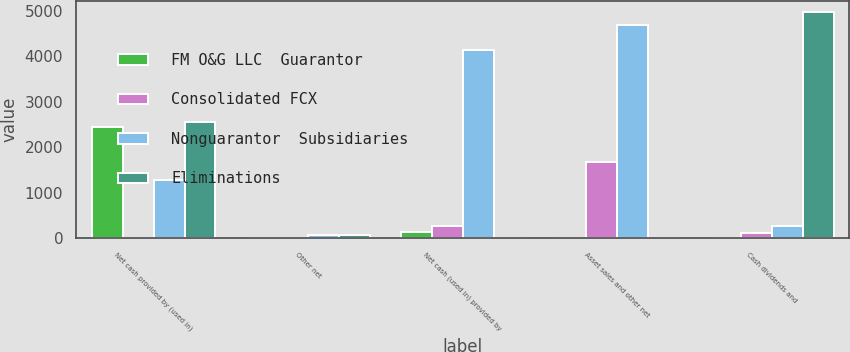Convert chart. <chart><loc_0><loc_0><loc_500><loc_500><stacked_bar_chart><ecel><fcel>Net cash provided by (used in)<fcel>Other net<fcel>Net cash (used in) provided by<fcel>Asset sales and other net<fcel>Cash dividends and<nl><fcel>FM O&G LLC  Guarantor<fcel>2449<fcel>10<fcel>137<fcel>2<fcel>6<nl><fcel>Consolidated FCX<fcel>17<fcel>10<fcel>271<fcel>1673<fcel>107<nl><fcel>Nonguarantor  Subsidiaries<fcel>1275<fcel>67<fcel>4135<fcel>4692<fcel>271<nl><fcel>Eliminations<fcel>2554<fcel>65<fcel>2<fcel>4<fcel>4969<nl></chart> 